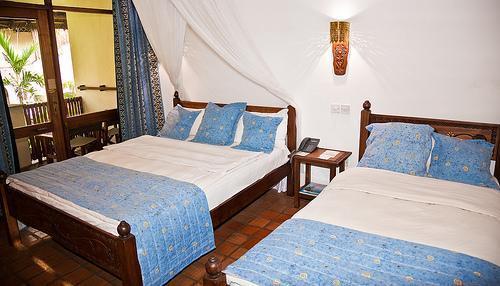How many pillows are in this room?
Give a very brief answer. 5. How many beds are in this room?
Give a very brief answer. 2. 